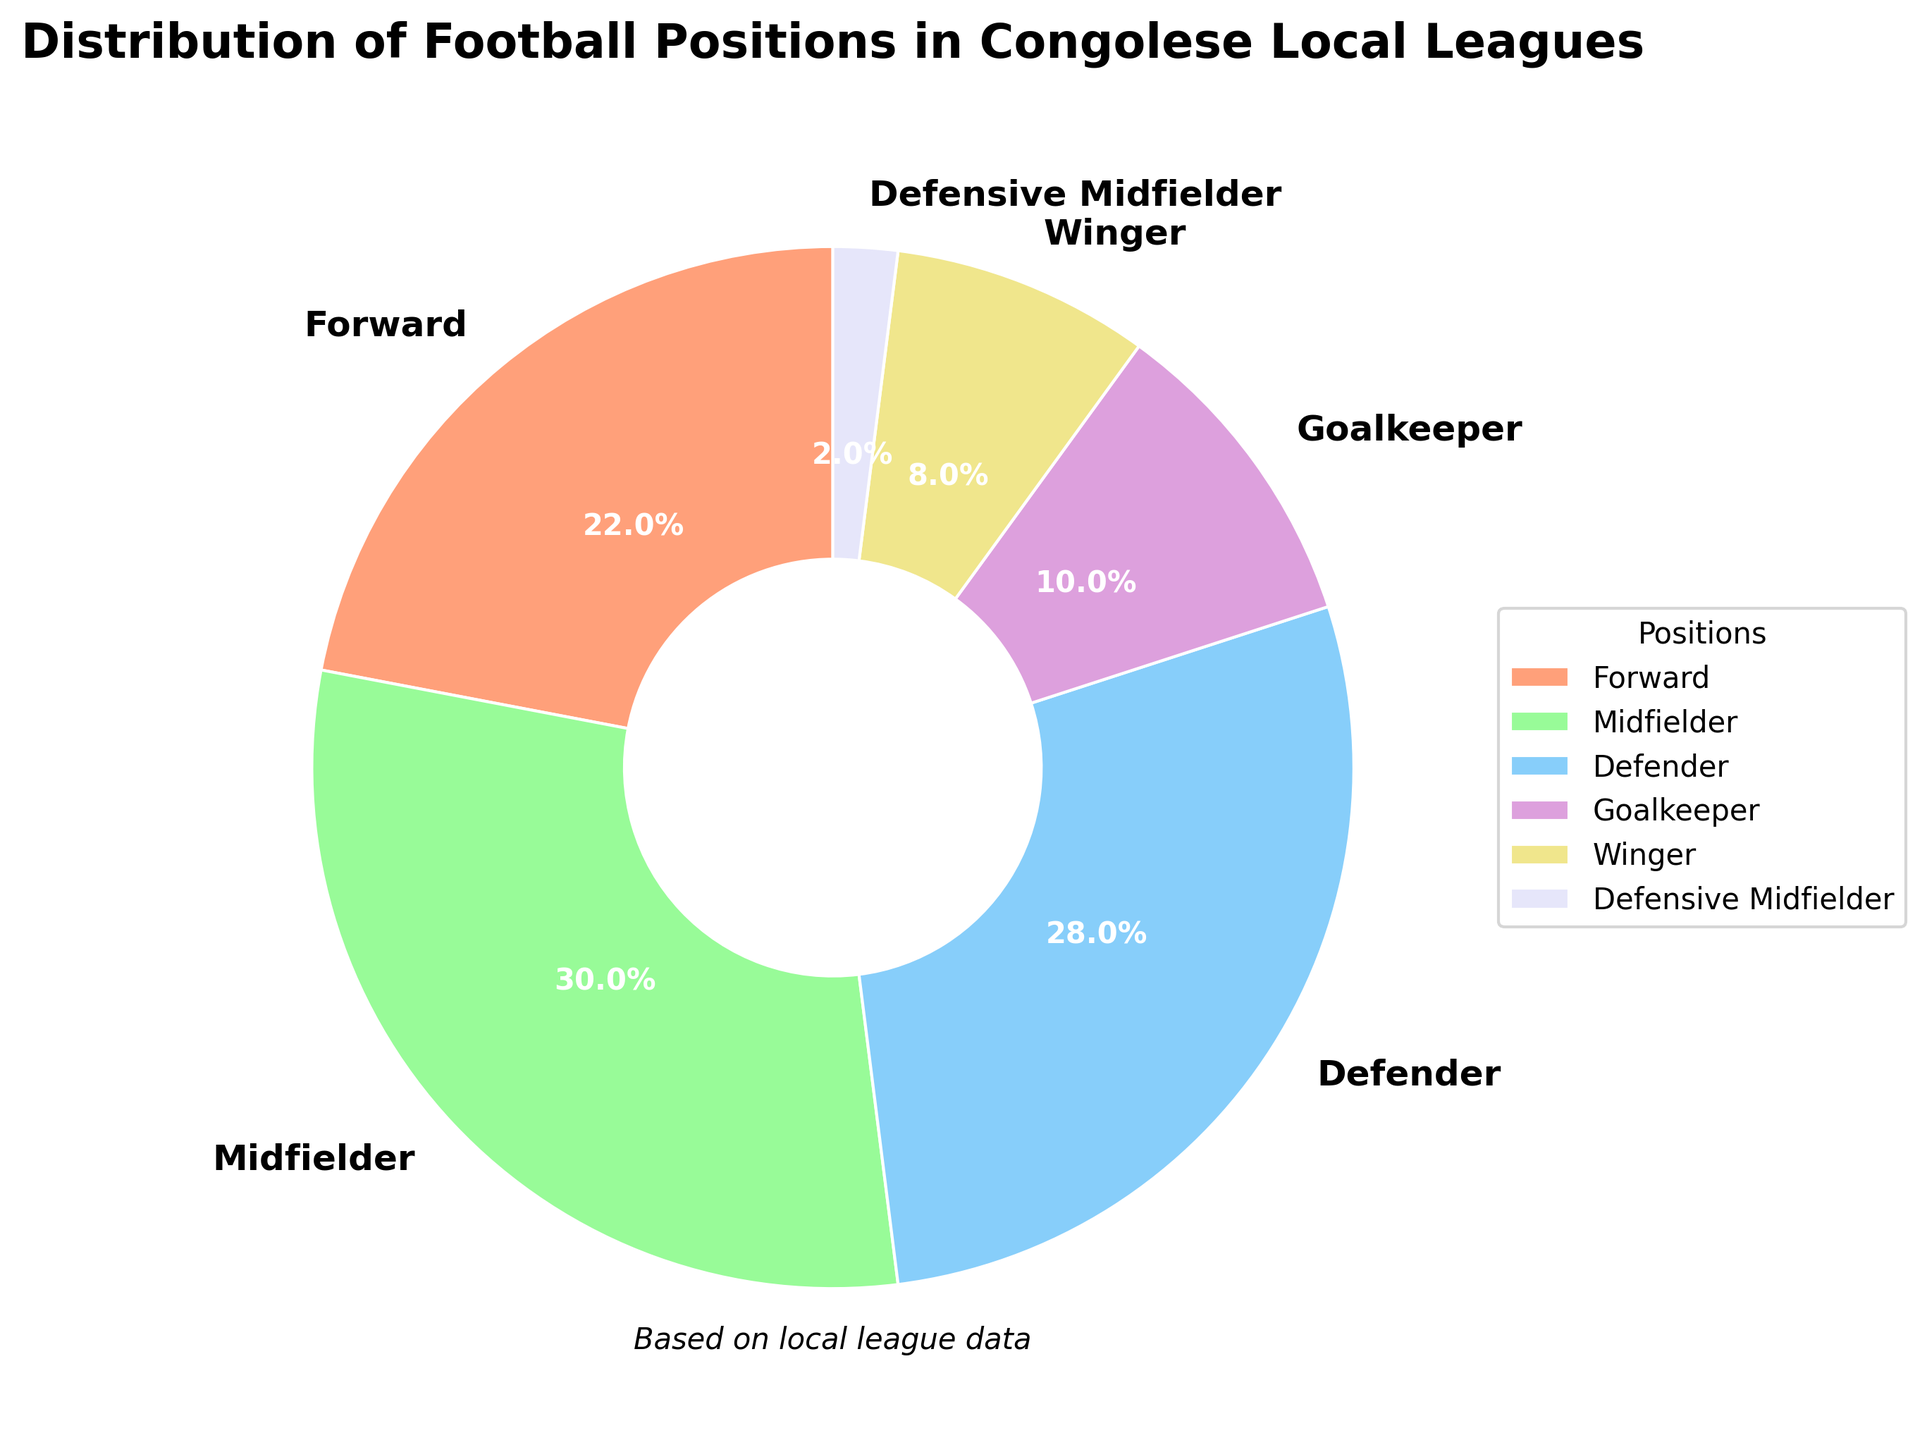What is the percentage of Forward players in Congolese local leagues? The percentage of Forward players is directly listed in the figure as 22%.
Answer: 22% Which position has the highest representation in Congolese local leagues? By looking at the percentages in the pie chart, the position with the highest percentage is Midfielder with 30%.
Answer: Midfielder What is the combined percentage of Defenders and Goalkeepers? To find the combined percentage of Defenders and Goalkeepers, sum their individual percentages: 28% (Defenders) + 10% (Goalkeepers) = 38%.
Answer: 38% Which position has the least representation? The position with the smallest percentage is Defensive Midfielder with 2%.
Answer: Defensive Midfielder How much more percentage of Midfielders are there compared to Wingers? Subtract the percentage of Wingers (8%) from Midfielders (30%): 30% - 8% = 22%.
Answer: 22% What color represents the position with the second highest percentage? The second highest percentage is Defenders (28%) and the pie chart color for Defenders is blue.
Answer: Blue How many positions have a percentage above 20%? The positions with percentages above 20% are Forward, Midfielder, and Defender, making a total of 3 positions.
Answer: 3 What is the average percentage of Forward, Midfielder, and Winger? To find the average percentage: (22% (Forward) + 30% (Midfielder) + 8% (Winger)) / 3 = 60% / 3 = 20%.
Answer: 20% What is the total percentage of players that are either Forwards or Wingers? Sum the percentages of Forwards and Wingers: 22% (Forwards) + 8% (Wingers) = 30%.
Answer: 30% Which color represents a position with a percentage lower than 10%? Positions with percentages lower than 10% are Goalkeeper (10%) and Defensive Midfielder (2%). Defensive Midfielder is represented with a light blue color.
Answer: Light blue 